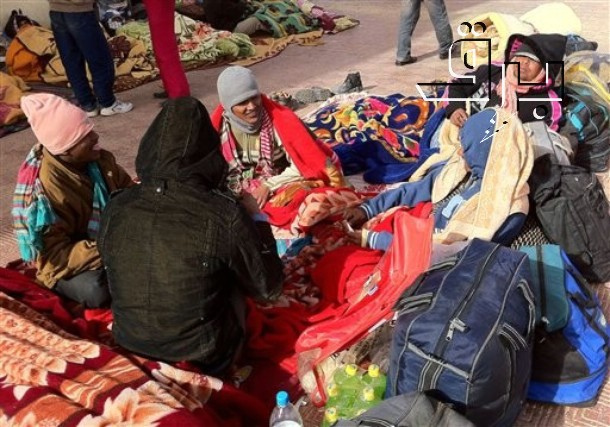If you were to transform this image into a painting, which elements would you emphasize? If transforming this image into a painting, I would emphasize the vivid colors of the blankets and clothing to create a stark contrast against the cold, perhaps snowy background. The warm hues would highlight the core theme of warmth and companionship in a cold environment. The expressions and body language of the individuals would be accentuated to convey a sense of mutual support and resilience. The urban backdrop with buildings and bare trees would be somewhat muted, ensuring that the focus remains on the people and their immediate surroundings. Additionally, subtle brushstrokes could be used to suggest a gentle aura around the group, symbolizing the warmth and positive energy they emanate despite their challenging circumstances. 